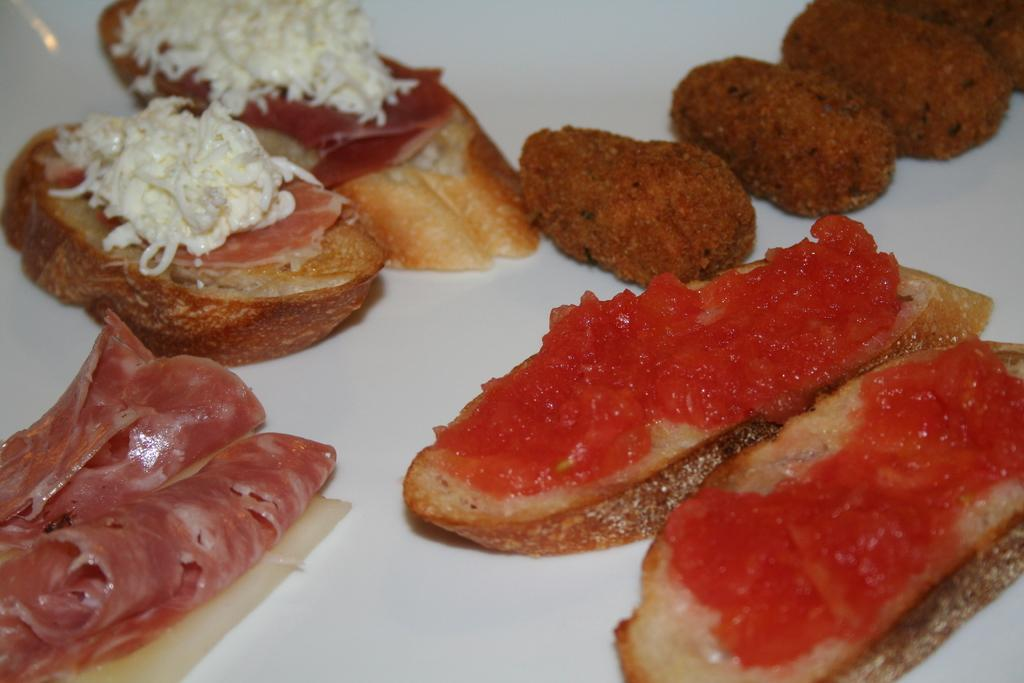What is on the plate in the image? There is food in the plate. What type of food can be seen in the plate? The food contains meat and cheese. Can you describe the specific ingredients in the food? The food contains meat and cheese as its main ingredients. What type of plants can be seen growing in the food? There are no plants visible in the food; it contains meat and cheese. How many mittens are present in the image? There are no mittens present in the image; it features a plate of food with meat and cheese. 